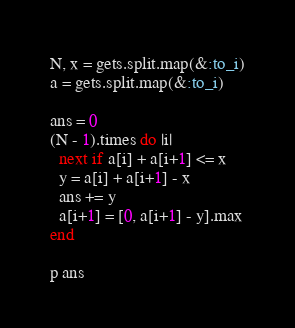<code> <loc_0><loc_0><loc_500><loc_500><_Ruby_>N, x = gets.split.map(&:to_i)
a = gets.split.map(&:to_i)

ans = 0
(N - 1).times do |i|
  next if a[i] + a[i+1] <= x
  y = a[i] + a[i+1] - x
  ans += y
  a[i+1] = [0, a[i+1] - y].max
end

p ans
</code> 